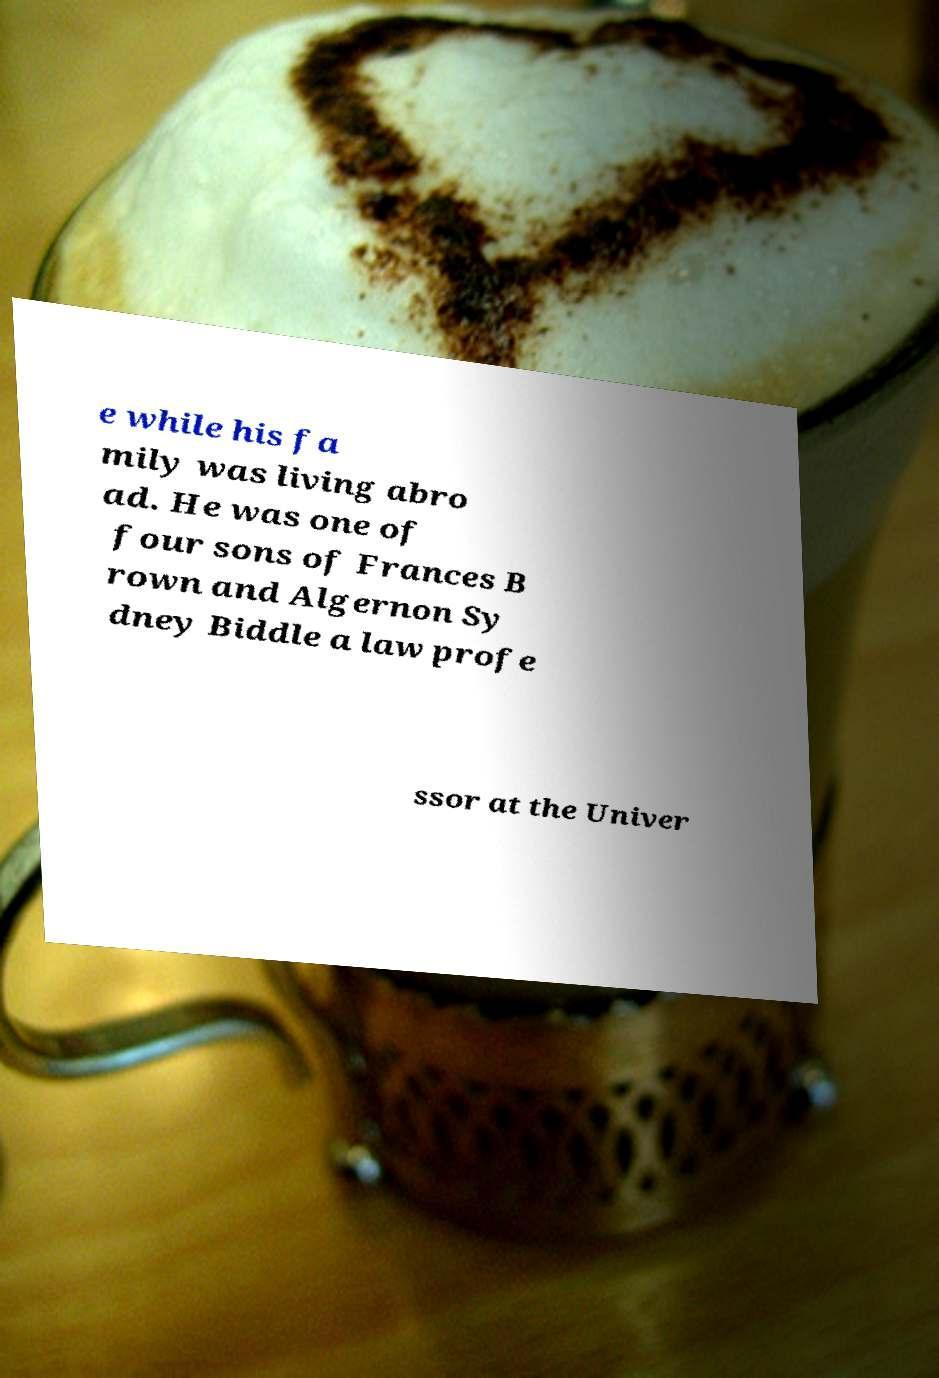For documentation purposes, I need the text within this image transcribed. Could you provide that? e while his fa mily was living abro ad. He was one of four sons of Frances B rown and Algernon Sy dney Biddle a law profe ssor at the Univer 